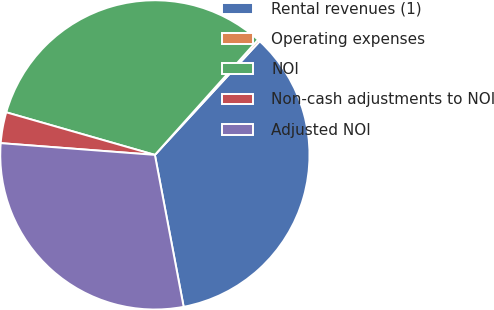<chart> <loc_0><loc_0><loc_500><loc_500><pie_chart><fcel>Rental revenues (1)<fcel>Operating expenses<fcel>NOI<fcel>Non-cash adjustments to NOI<fcel>Adjusted NOI<nl><fcel>35.16%<fcel>0.24%<fcel>32.18%<fcel>3.23%<fcel>29.19%<nl></chart> 